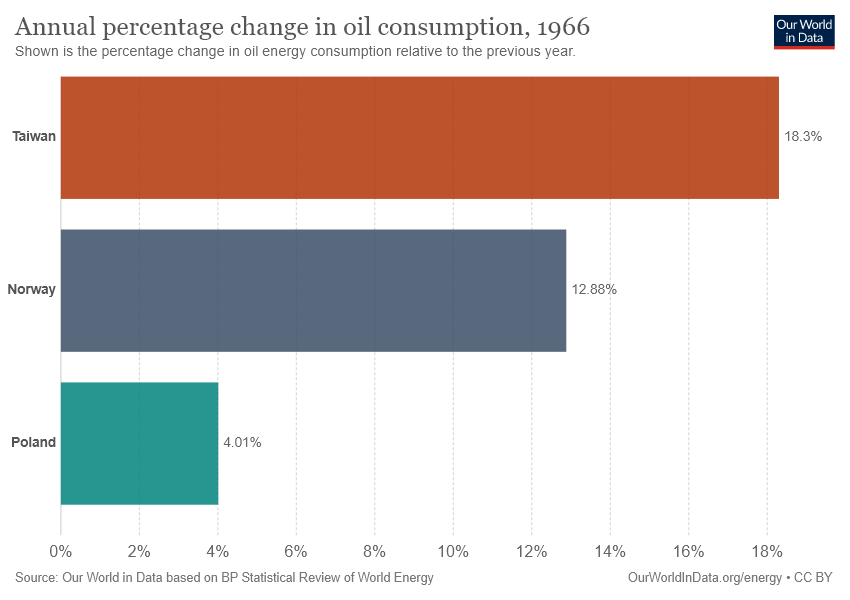Indicate a few pertinent items in this graphic. Poland has the lowest annual percentage change in oil consumption compared to other countries. The average percentage change in oil consumption among the three countries was 0.1173. 